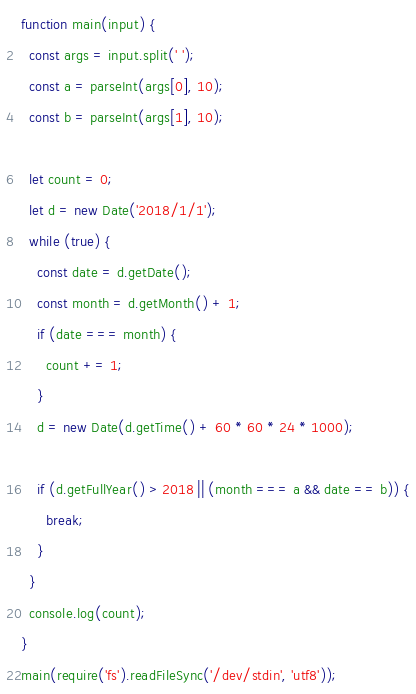<code> <loc_0><loc_0><loc_500><loc_500><_JavaScript_>function main(input) {
  const args = input.split(' ');
  const a = parseInt(args[0], 10);
  const b = parseInt(args[1], 10);

  let count = 0;
  let d = new Date('2018/1/1');
  while (true) {
    const date = d.getDate();
    const month = d.getMonth() + 1;
    if (date === month) {
      count += 1;
    }
    d = new Date(d.getTime() + 60 * 60 * 24 * 1000);

    if (d.getFullYear() > 2018 || (month === a && date == b)) {
      break;
    }
  }
  console.log(count);
}
main(require('fs').readFileSync('/dev/stdin', 'utf8'));
</code> 